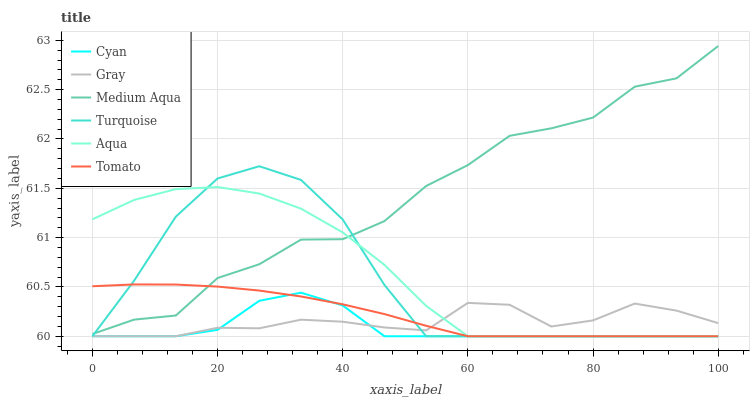Does Gray have the minimum area under the curve?
Answer yes or no. No. Does Gray have the maximum area under the curve?
Answer yes or no. No. Is Gray the smoothest?
Answer yes or no. No. Is Gray the roughest?
Answer yes or no. No. Does Medium Aqua have the lowest value?
Answer yes or no. No. Does Turquoise have the highest value?
Answer yes or no. No. Is Gray less than Medium Aqua?
Answer yes or no. Yes. Is Medium Aqua greater than Gray?
Answer yes or no. Yes. Does Gray intersect Medium Aqua?
Answer yes or no. No. 